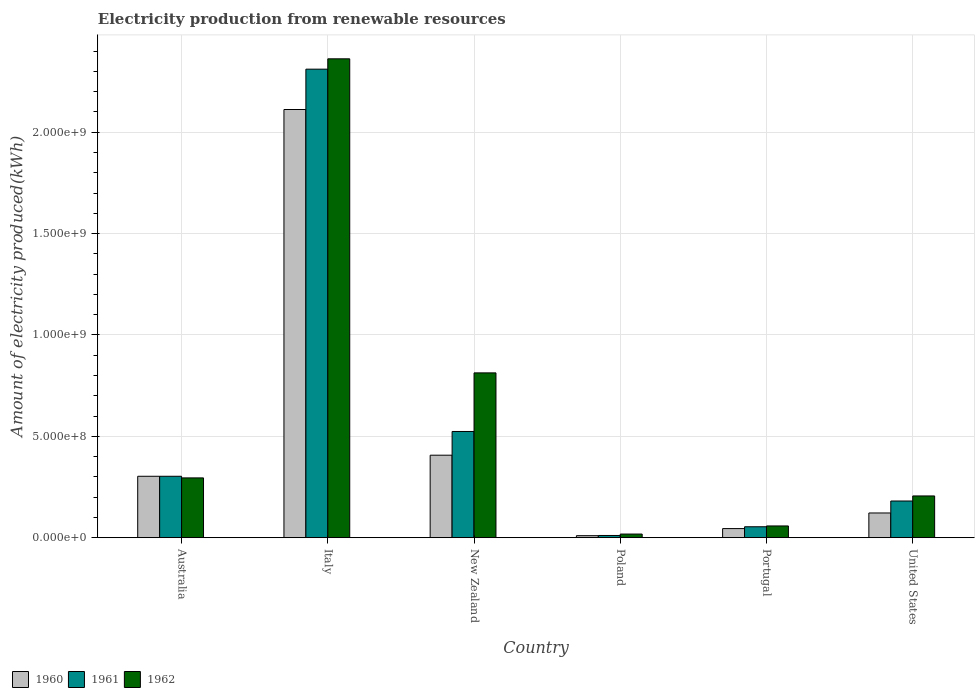How many different coloured bars are there?
Offer a terse response. 3. Are the number of bars on each tick of the X-axis equal?
Your answer should be very brief. Yes. How many bars are there on the 4th tick from the left?
Ensure brevity in your answer.  3. How many bars are there on the 3rd tick from the right?
Ensure brevity in your answer.  3. In how many cases, is the number of bars for a given country not equal to the number of legend labels?
Offer a very short reply. 0. What is the amount of electricity produced in 1961 in Portugal?
Keep it short and to the point. 5.40e+07. Across all countries, what is the maximum amount of electricity produced in 1960?
Give a very brief answer. 2.11e+09. Across all countries, what is the minimum amount of electricity produced in 1960?
Make the answer very short. 1.00e+07. In which country was the amount of electricity produced in 1962 maximum?
Provide a short and direct response. Italy. What is the total amount of electricity produced in 1960 in the graph?
Give a very brief answer. 3.00e+09. What is the difference between the amount of electricity produced in 1962 in Australia and that in Poland?
Offer a very short reply. 2.77e+08. What is the difference between the amount of electricity produced in 1961 in Portugal and the amount of electricity produced in 1962 in Italy?
Provide a short and direct response. -2.31e+09. What is the average amount of electricity produced in 1962 per country?
Your response must be concise. 6.25e+08. What is the difference between the amount of electricity produced of/in 1960 and amount of electricity produced of/in 1962 in United States?
Make the answer very short. -8.40e+07. What is the ratio of the amount of electricity produced in 1962 in Australia to that in United States?
Make the answer very short. 1.43. Is the amount of electricity produced in 1960 in Portugal less than that in United States?
Your response must be concise. Yes. Is the difference between the amount of electricity produced in 1960 in Australia and United States greater than the difference between the amount of electricity produced in 1962 in Australia and United States?
Your response must be concise. Yes. What is the difference between the highest and the second highest amount of electricity produced in 1961?
Offer a very short reply. 1.79e+09. What is the difference between the highest and the lowest amount of electricity produced in 1960?
Your answer should be compact. 2.10e+09. In how many countries, is the amount of electricity produced in 1962 greater than the average amount of electricity produced in 1962 taken over all countries?
Offer a very short reply. 2. Is the sum of the amount of electricity produced in 1961 in Australia and Italy greater than the maximum amount of electricity produced in 1962 across all countries?
Provide a short and direct response. Yes. How many countries are there in the graph?
Keep it short and to the point. 6. Does the graph contain any zero values?
Your answer should be compact. No. Does the graph contain grids?
Provide a short and direct response. Yes. What is the title of the graph?
Keep it short and to the point. Electricity production from renewable resources. What is the label or title of the X-axis?
Your answer should be compact. Country. What is the label or title of the Y-axis?
Offer a terse response. Amount of electricity produced(kWh). What is the Amount of electricity produced(kWh) in 1960 in Australia?
Your response must be concise. 3.03e+08. What is the Amount of electricity produced(kWh) of 1961 in Australia?
Ensure brevity in your answer.  3.03e+08. What is the Amount of electricity produced(kWh) of 1962 in Australia?
Make the answer very short. 2.95e+08. What is the Amount of electricity produced(kWh) in 1960 in Italy?
Provide a short and direct response. 2.11e+09. What is the Amount of electricity produced(kWh) in 1961 in Italy?
Keep it short and to the point. 2.31e+09. What is the Amount of electricity produced(kWh) of 1962 in Italy?
Provide a short and direct response. 2.36e+09. What is the Amount of electricity produced(kWh) of 1960 in New Zealand?
Offer a terse response. 4.07e+08. What is the Amount of electricity produced(kWh) of 1961 in New Zealand?
Provide a short and direct response. 5.24e+08. What is the Amount of electricity produced(kWh) of 1962 in New Zealand?
Your answer should be very brief. 8.13e+08. What is the Amount of electricity produced(kWh) in 1961 in Poland?
Provide a short and direct response. 1.10e+07. What is the Amount of electricity produced(kWh) in 1962 in Poland?
Your answer should be very brief. 1.80e+07. What is the Amount of electricity produced(kWh) in 1960 in Portugal?
Offer a very short reply. 4.50e+07. What is the Amount of electricity produced(kWh) in 1961 in Portugal?
Your answer should be compact. 5.40e+07. What is the Amount of electricity produced(kWh) of 1962 in Portugal?
Provide a short and direct response. 5.80e+07. What is the Amount of electricity produced(kWh) in 1960 in United States?
Keep it short and to the point. 1.22e+08. What is the Amount of electricity produced(kWh) in 1961 in United States?
Your answer should be very brief. 1.81e+08. What is the Amount of electricity produced(kWh) in 1962 in United States?
Your answer should be very brief. 2.06e+08. Across all countries, what is the maximum Amount of electricity produced(kWh) in 1960?
Make the answer very short. 2.11e+09. Across all countries, what is the maximum Amount of electricity produced(kWh) of 1961?
Your answer should be very brief. 2.31e+09. Across all countries, what is the maximum Amount of electricity produced(kWh) of 1962?
Ensure brevity in your answer.  2.36e+09. Across all countries, what is the minimum Amount of electricity produced(kWh) of 1961?
Offer a very short reply. 1.10e+07. Across all countries, what is the minimum Amount of electricity produced(kWh) in 1962?
Provide a short and direct response. 1.80e+07. What is the total Amount of electricity produced(kWh) in 1960 in the graph?
Give a very brief answer. 3.00e+09. What is the total Amount of electricity produced(kWh) of 1961 in the graph?
Give a very brief answer. 3.38e+09. What is the total Amount of electricity produced(kWh) of 1962 in the graph?
Offer a terse response. 3.75e+09. What is the difference between the Amount of electricity produced(kWh) of 1960 in Australia and that in Italy?
Keep it short and to the point. -1.81e+09. What is the difference between the Amount of electricity produced(kWh) in 1961 in Australia and that in Italy?
Offer a very short reply. -2.01e+09. What is the difference between the Amount of electricity produced(kWh) in 1962 in Australia and that in Italy?
Provide a succinct answer. -2.07e+09. What is the difference between the Amount of electricity produced(kWh) of 1960 in Australia and that in New Zealand?
Provide a short and direct response. -1.04e+08. What is the difference between the Amount of electricity produced(kWh) in 1961 in Australia and that in New Zealand?
Your answer should be very brief. -2.21e+08. What is the difference between the Amount of electricity produced(kWh) of 1962 in Australia and that in New Zealand?
Your response must be concise. -5.18e+08. What is the difference between the Amount of electricity produced(kWh) of 1960 in Australia and that in Poland?
Make the answer very short. 2.93e+08. What is the difference between the Amount of electricity produced(kWh) in 1961 in Australia and that in Poland?
Your response must be concise. 2.92e+08. What is the difference between the Amount of electricity produced(kWh) in 1962 in Australia and that in Poland?
Your answer should be very brief. 2.77e+08. What is the difference between the Amount of electricity produced(kWh) of 1960 in Australia and that in Portugal?
Offer a very short reply. 2.58e+08. What is the difference between the Amount of electricity produced(kWh) in 1961 in Australia and that in Portugal?
Provide a succinct answer. 2.49e+08. What is the difference between the Amount of electricity produced(kWh) in 1962 in Australia and that in Portugal?
Your response must be concise. 2.37e+08. What is the difference between the Amount of electricity produced(kWh) in 1960 in Australia and that in United States?
Your response must be concise. 1.81e+08. What is the difference between the Amount of electricity produced(kWh) in 1961 in Australia and that in United States?
Your answer should be compact. 1.22e+08. What is the difference between the Amount of electricity produced(kWh) in 1962 in Australia and that in United States?
Provide a succinct answer. 8.90e+07. What is the difference between the Amount of electricity produced(kWh) of 1960 in Italy and that in New Zealand?
Your answer should be compact. 1.70e+09. What is the difference between the Amount of electricity produced(kWh) of 1961 in Italy and that in New Zealand?
Make the answer very short. 1.79e+09. What is the difference between the Amount of electricity produced(kWh) in 1962 in Italy and that in New Zealand?
Give a very brief answer. 1.55e+09. What is the difference between the Amount of electricity produced(kWh) in 1960 in Italy and that in Poland?
Make the answer very short. 2.10e+09. What is the difference between the Amount of electricity produced(kWh) in 1961 in Italy and that in Poland?
Offer a terse response. 2.30e+09. What is the difference between the Amount of electricity produced(kWh) of 1962 in Italy and that in Poland?
Keep it short and to the point. 2.34e+09. What is the difference between the Amount of electricity produced(kWh) of 1960 in Italy and that in Portugal?
Offer a very short reply. 2.07e+09. What is the difference between the Amount of electricity produced(kWh) in 1961 in Italy and that in Portugal?
Provide a succinct answer. 2.26e+09. What is the difference between the Amount of electricity produced(kWh) in 1962 in Italy and that in Portugal?
Keep it short and to the point. 2.30e+09. What is the difference between the Amount of electricity produced(kWh) in 1960 in Italy and that in United States?
Provide a succinct answer. 1.99e+09. What is the difference between the Amount of electricity produced(kWh) in 1961 in Italy and that in United States?
Provide a succinct answer. 2.13e+09. What is the difference between the Amount of electricity produced(kWh) in 1962 in Italy and that in United States?
Keep it short and to the point. 2.16e+09. What is the difference between the Amount of electricity produced(kWh) in 1960 in New Zealand and that in Poland?
Keep it short and to the point. 3.97e+08. What is the difference between the Amount of electricity produced(kWh) of 1961 in New Zealand and that in Poland?
Provide a succinct answer. 5.13e+08. What is the difference between the Amount of electricity produced(kWh) of 1962 in New Zealand and that in Poland?
Your response must be concise. 7.95e+08. What is the difference between the Amount of electricity produced(kWh) of 1960 in New Zealand and that in Portugal?
Ensure brevity in your answer.  3.62e+08. What is the difference between the Amount of electricity produced(kWh) in 1961 in New Zealand and that in Portugal?
Provide a short and direct response. 4.70e+08. What is the difference between the Amount of electricity produced(kWh) of 1962 in New Zealand and that in Portugal?
Ensure brevity in your answer.  7.55e+08. What is the difference between the Amount of electricity produced(kWh) of 1960 in New Zealand and that in United States?
Your answer should be compact. 2.85e+08. What is the difference between the Amount of electricity produced(kWh) in 1961 in New Zealand and that in United States?
Keep it short and to the point. 3.43e+08. What is the difference between the Amount of electricity produced(kWh) in 1962 in New Zealand and that in United States?
Keep it short and to the point. 6.07e+08. What is the difference between the Amount of electricity produced(kWh) in 1960 in Poland and that in Portugal?
Offer a terse response. -3.50e+07. What is the difference between the Amount of electricity produced(kWh) of 1961 in Poland and that in Portugal?
Offer a terse response. -4.30e+07. What is the difference between the Amount of electricity produced(kWh) in 1962 in Poland and that in Portugal?
Your answer should be very brief. -4.00e+07. What is the difference between the Amount of electricity produced(kWh) in 1960 in Poland and that in United States?
Make the answer very short. -1.12e+08. What is the difference between the Amount of electricity produced(kWh) in 1961 in Poland and that in United States?
Offer a terse response. -1.70e+08. What is the difference between the Amount of electricity produced(kWh) of 1962 in Poland and that in United States?
Make the answer very short. -1.88e+08. What is the difference between the Amount of electricity produced(kWh) of 1960 in Portugal and that in United States?
Your answer should be very brief. -7.70e+07. What is the difference between the Amount of electricity produced(kWh) in 1961 in Portugal and that in United States?
Provide a short and direct response. -1.27e+08. What is the difference between the Amount of electricity produced(kWh) of 1962 in Portugal and that in United States?
Make the answer very short. -1.48e+08. What is the difference between the Amount of electricity produced(kWh) of 1960 in Australia and the Amount of electricity produced(kWh) of 1961 in Italy?
Offer a very short reply. -2.01e+09. What is the difference between the Amount of electricity produced(kWh) of 1960 in Australia and the Amount of electricity produced(kWh) of 1962 in Italy?
Your answer should be very brief. -2.06e+09. What is the difference between the Amount of electricity produced(kWh) of 1961 in Australia and the Amount of electricity produced(kWh) of 1962 in Italy?
Your answer should be compact. -2.06e+09. What is the difference between the Amount of electricity produced(kWh) in 1960 in Australia and the Amount of electricity produced(kWh) in 1961 in New Zealand?
Make the answer very short. -2.21e+08. What is the difference between the Amount of electricity produced(kWh) in 1960 in Australia and the Amount of electricity produced(kWh) in 1962 in New Zealand?
Your answer should be compact. -5.10e+08. What is the difference between the Amount of electricity produced(kWh) in 1961 in Australia and the Amount of electricity produced(kWh) in 1962 in New Zealand?
Make the answer very short. -5.10e+08. What is the difference between the Amount of electricity produced(kWh) in 1960 in Australia and the Amount of electricity produced(kWh) in 1961 in Poland?
Make the answer very short. 2.92e+08. What is the difference between the Amount of electricity produced(kWh) in 1960 in Australia and the Amount of electricity produced(kWh) in 1962 in Poland?
Keep it short and to the point. 2.85e+08. What is the difference between the Amount of electricity produced(kWh) in 1961 in Australia and the Amount of electricity produced(kWh) in 1962 in Poland?
Keep it short and to the point. 2.85e+08. What is the difference between the Amount of electricity produced(kWh) of 1960 in Australia and the Amount of electricity produced(kWh) of 1961 in Portugal?
Your answer should be compact. 2.49e+08. What is the difference between the Amount of electricity produced(kWh) in 1960 in Australia and the Amount of electricity produced(kWh) in 1962 in Portugal?
Give a very brief answer. 2.45e+08. What is the difference between the Amount of electricity produced(kWh) in 1961 in Australia and the Amount of electricity produced(kWh) in 1962 in Portugal?
Offer a very short reply. 2.45e+08. What is the difference between the Amount of electricity produced(kWh) of 1960 in Australia and the Amount of electricity produced(kWh) of 1961 in United States?
Make the answer very short. 1.22e+08. What is the difference between the Amount of electricity produced(kWh) of 1960 in Australia and the Amount of electricity produced(kWh) of 1962 in United States?
Ensure brevity in your answer.  9.70e+07. What is the difference between the Amount of electricity produced(kWh) of 1961 in Australia and the Amount of electricity produced(kWh) of 1962 in United States?
Offer a terse response. 9.70e+07. What is the difference between the Amount of electricity produced(kWh) of 1960 in Italy and the Amount of electricity produced(kWh) of 1961 in New Zealand?
Your response must be concise. 1.59e+09. What is the difference between the Amount of electricity produced(kWh) of 1960 in Italy and the Amount of electricity produced(kWh) of 1962 in New Zealand?
Offer a terse response. 1.30e+09. What is the difference between the Amount of electricity produced(kWh) in 1961 in Italy and the Amount of electricity produced(kWh) in 1962 in New Zealand?
Give a very brief answer. 1.50e+09. What is the difference between the Amount of electricity produced(kWh) of 1960 in Italy and the Amount of electricity produced(kWh) of 1961 in Poland?
Your answer should be compact. 2.10e+09. What is the difference between the Amount of electricity produced(kWh) of 1960 in Italy and the Amount of electricity produced(kWh) of 1962 in Poland?
Your answer should be very brief. 2.09e+09. What is the difference between the Amount of electricity produced(kWh) of 1961 in Italy and the Amount of electricity produced(kWh) of 1962 in Poland?
Your answer should be very brief. 2.29e+09. What is the difference between the Amount of electricity produced(kWh) of 1960 in Italy and the Amount of electricity produced(kWh) of 1961 in Portugal?
Make the answer very short. 2.06e+09. What is the difference between the Amount of electricity produced(kWh) in 1960 in Italy and the Amount of electricity produced(kWh) in 1962 in Portugal?
Your answer should be compact. 2.05e+09. What is the difference between the Amount of electricity produced(kWh) of 1961 in Italy and the Amount of electricity produced(kWh) of 1962 in Portugal?
Ensure brevity in your answer.  2.25e+09. What is the difference between the Amount of electricity produced(kWh) in 1960 in Italy and the Amount of electricity produced(kWh) in 1961 in United States?
Your answer should be very brief. 1.93e+09. What is the difference between the Amount of electricity produced(kWh) of 1960 in Italy and the Amount of electricity produced(kWh) of 1962 in United States?
Provide a succinct answer. 1.91e+09. What is the difference between the Amount of electricity produced(kWh) of 1961 in Italy and the Amount of electricity produced(kWh) of 1962 in United States?
Your answer should be very brief. 2.10e+09. What is the difference between the Amount of electricity produced(kWh) in 1960 in New Zealand and the Amount of electricity produced(kWh) in 1961 in Poland?
Your response must be concise. 3.96e+08. What is the difference between the Amount of electricity produced(kWh) of 1960 in New Zealand and the Amount of electricity produced(kWh) of 1962 in Poland?
Your answer should be compact. 3.89e+08. What is the difference between the Amount of electricity produced(kWh) in 1961 in New Zealand and the Amount of electricity produced(kWh) in 1962 in Poland?
Offer a very short reply. 5.06e+08. What is the difference between the Amount of electricity produced(kWh) of 1960 in New Zealand and the Amount of electricity produced(kWh) of 1961 in Portugal?
Make the answer very short. 3.53e+08. What is the difference between the Amount of electricity produced(kWh) of 1960 in New Zealand and the Amount of electricity produced(kWh) of 1962 in Portugal?
Offer a terse response. 3.49e+08. What is the difference between the Amount of electricity produced(kWh) in 1961 in New Zealand and the Amount of electricity produced(kWh) in 1962 in Portugal?
Your answer should be compact. 4.66e+08. What is the difference between the Amount of electricity produced(kWh) of 1960 in New Zealand and the Amount of electricity produced(kWh) of 1961 in United States?
Your answer should be compact. 2.26e+08. What is the difference between the Amount of electricity produced(kWh) of 1960 in New Zealand and the Amount of electricity produced(kWh) of 1962 in United States?
Ensure brevity in your answer.  2.01e+08. What is the difference between the Amount of electricity produced(kWh) of 1961 in New Zealand and the Amount of electricity produced(kWh) of 1962 in United States?
Your response must be concise. 3.18e+08. What is the difference between the Amount of electricity produced(kWh) in 1960 in Poland and the Amount of electricity produced(kWh) in 1961 in Portugal?
Provide a succinct answer. -4.40e+07. What is the difference between the Amount of electricity produced(kWh) of 1960 in Poland and the Amount of electricity produced(kWh) of 1962 in Portugal?
Provide a short and direct response. -4.80e+07. What is the difference between the Amount of electricity produced(kWh) of 1961 in Poland and the Amount of electricity produced(kWh) of 1962 in Portugal?
Keep it short and to the point. -4.70e+07. What is the difference between the Amount of electricity produced(kWh) in 1960 in Poland and the Amount of electricity produced(kWh) in 1961 in United States?
Provide a succinct answer. -1.71e+08. What is the difference between the Amount of electricity produced(kWh) in 1960 in Poland and the Amount of electricity produced(kWh) in 1962 in United States?
Give a very brief answer. -1.96e+08. What is the difference between the Amount of electricity produced(kWh) of 1961 in Poland and the Amount of electricity produced(kWh) of 1962 in United States?
Your answer should be compact. -1.95e+08. What is the difference between the Amount of electricity produced(kWh) in 1960 in Portugal and the Amount of electricity produced(kWh) in 1961 in United States?
Keep it short and to the point. -1.36e+08. What is the difference between the Amount of electricity produced(kWh) in 1960 in Portugal and the Amount of electricity produced(kWh) in 1962 in United States?
Your answer should be compact. -1.61e+08. What is the difference between the Amount of electricity produced(kWh) of 1961 in Portugal and the Amount of electricity produced(kWh) of 1962 in United States?
Your answer should be compact. -1.52e+08. What is the average Amount of electricity produced(kWh) of 1960 per country?
Give a very brief answer. 5.00e+08. What is the average Amount of electricity produced(kWh) in 1961 per country?
Your answer should be compact. 5.64e+08. What is the average Amount of electricity produced(kWh) in 1962 per country?
Keep it short and to the point. 6.25e+08. What is the difference between the Amount of electricity produced(kWh) in 1960 and Amount of electricity produced(kWh) in 1961 in Australia?
Offer a very short reply. 0. What is the difference between the Amount of electricity produced(kWh) of 1960 and Amount of electricity produced(kWh) of 1961 in Italy?
Offer a very short reply. -1.99e+08. What is the difference between the Amount of electricity produced(kWh) in 1960 and Amount of electricity produced(kWh) in 1962 in Italy?
Make the answer very short. -2.50e+08. What is the difference between the Amount of electricity produced(kWh) in 1961 and Amount of electricity produced(kWh) in 1962 in Italy?
Provide a succinct answer. -5.10e+07. What is the difference between the Amount of electricity produced(kWh) of 1960 and Amount of electricity produced(kWh) of 1961 in New Zealand?
Keep it short and to the point. -1.17e+08. What is the difference between the Amount of electricity produced(kWh) in 1960 and Amount of electricity produced(kWh) in 1962 in New Zealand?
Keep it short and to the point. -4.06e+08. What is the difference between the Amount of electricity produced(kWh) in 1961 and Amount of electricity produced(kWh) in 1962 in New Zealand?
Provide a short and direct response. -2.89e+08. What is the difference between the Amount of electricity produced(kWh) of 1960 and Amount of electricity produced(kWh) of 1962 in Poland?
Offer a very short reply. -8.00e+06. What is the difference between the Amount of electricity produced(kWh) in 1961 and Amount of electricity produced(kWh) in 1962 in Poland?
Ensure brevity in your answer.  -7.00e+06. What is the difference between the Amount of electricity produced(kWh) in 1960 and Amount of electricity produced(kWh) in 1961 in Portugal?
Keep it short and to the point. -9.00e+06. What is the difference between the Amount of electricity produced(kWh) of 1960 and Amount of electricity produced(kWh) of 1962 in Portugal?
Ensure brevity in your answer.  -1.30e+07. What is the difference between the Amount of electricity produced(kWh) of 1961 and Amount of electricity produced(kWh) of 1962 in Portugal?
Offer a very short reply. -4.00e+06. What is the difference between the Amount of electricity produced(kWh) of 1960 and Amount of electricity produced(kWh) of 1961 in United States?
Ensure brevity in your answer.  -5.90e+07. What is the difference between the Amount of electricity produced(kWh) in 1960 and Amount of electricity produced(kWh) in 1962 in United States?
Your response must be concise. -8.40e+07. What is the difference between the Amount of electricity produced(kWh) in 1961 and Amount of electricity produced(kWh) in 1962 in United States?
Make the answer very short. -2.50e+07. What is the ratio of the Amount of electricity produced(kWh) of 1960 in Australia to that in Italy?
Your response must be concise. 0.14. What is the ratio of the Amount of electricity produced(kWh) in 1961 in Australia to that in Italy?
Your response must be concise. 0.13. What is the ratio of the Amount of electricity produced(kWh) in 1962 in Australia to that in Italy?
Provide a short and direct response. 0.12. What is the ratio of the Amount of electricity produced(kWh) of 1960 in Australia to that in New Zealand?
Ensure brevity in your answer.  0.74. What is the ratio of the Amount of electricity produced(kWh) of 1961 in Australia to that in New Zealand?
Your answer should be compact. 0.58. What is the ratio of the Amount of electricity produced(kWh) in 1962 in Australia to that in New Zealand?
Make the answer very short. 0.36. What is the ratio of the Amount of electricity produced(kWh) in 1960 in Australia to that in Poland?
Offer a very short reply. 30.3. What is the ratio of the Amount of electricity produced(kWh) of 1961 in Australia to that in Poland?
Your answer should be compact. 27.55. What is the ratio of the Amount of electricity produced(kWh) in 1962 in Australia to that in Poland?
Ensure brevity in your answer.  16.39. What is the ratio of the Amount of electricity produced(kWh) of 1960 in Australia to that in Portugal?
Your response must be concise. 6.73. What is the ratio of the Amount of electricity produced(kWh) of 1961 in Australia to that in Portugal?
Keep it short and to the point. 5.61. What is the ratio of the Amount of electricity produced(kWh) of 1962 in Australia to that in Portugal?
Give a very brief answer. 5.09. What is the ratio of the Amount of electricity produced(kWh) in 1960 in Australia to that in United States?
Provide a succinct answer. 2.48. What is the ratio of the Amount of electricity produced(kWh) in 1961 in Australia to that in United States?
Your response must be concise. 1.67. What is the ratio of the Amount of electricity produced(kWh) of 1962 in Australia to that in United States?
Make the answer very short. 1.43. What is the ratio of the Amount of electricity produced(kWh) of 1960 in Italy to that in New Zealand?
Give a very brief answer. 5.19. What is the ratio of the Amount of electricity produced(kWh) in 1961 in Italy to that in New Zealand?
Ensure brevity in your answer.  4.41. What is the ratio of the Amount of electricity produced(kWh) in 1962 in Italy to that in New Zealand?
Your response must be concise. 2.91. What is the ratio of the Amount of electricity produced(kWh) of 1960 in Italy to that in Poland?
Your answer should be compact. 211.2. What is the ratio of the Amount of electricity produced(kWh) in 1961 in Italy to that in Poland?
Provide a short and direct response. 210.09. What is the ratio of the Amount of electricity produced(kWh) of 1962 in Italy to that in Poland?
Offer a very short reply. 131.22. What is the ratio of the Amount of electricity produced(kWh) of 1960 in Italy to that in Portugal?
Provide a succinct answer. 46.93. What is the ratio of the Amount of electricity produced(kWh) of 1961 in Italy to that in Portugal?
Your response must be concise. 42.8. What is the ratio of the Amount of electricity produced(kWh) in 1962 in Italy to that in Portugal?
Provide a short and direct response. 40.72. What is the ratio of the Amount of electricity produced(kWh) of 1960 in Italy to that in United States?
Your response must be concise. 17.31. What is the ratio of the Amount of electricity produced(kWh) in 1961 in Italy to that in United States?
Your response must be concise. 12.77. What is the ratio of the Amount of electricity produced(kWh) in 1962 in Italy to that in United States?
Make the answer very short. 11.47. What is the ratio of the Amount of electricity produced(kWh) in 1960 in New Zealand to that in Poland?
Make the answer very short. 40.7. What is the ratio of the Amount of electricity produced(kWh) in 1961 in New Zealand to that in Poland?
Your answer should be compact. 47.64. What is the ratio of the Amount of electricity produced(kWh) of 1962 in New Zealand to that in Poland?
Your answer should be compact. 45.17. What is the ratio of the Amount of electricity produced(kWh) in 1960 in New Zealand to that in Portugal?
Offer a very short reply. 9.04. What is the ratio of the Amount of electricity produced(kWh) of 1961 in New Zealand to that in Portugal?
Offer a very short reply. 9.7. What is the ratio of the Amount of electricity produced(kWh) in 1962 in New Zealand to that in Portugal?
Your response must be concise. 14.02. What is the ratio of the Amount of electricity produced(kWh) in 1960 in New Zealand to that in United States?
Make the answer very short. 3.34. What is the ratio of the Amount of electricity produced(kWh) of 1961 in New Zealand to that in United States?
Provide a succinct answer. 2.9. What is the ratio of the Amount of electricity produced(kWh) of 1962 in New Zealand to that in United States?
Ensure brevity in your answer.  3.95. What is the ratio of the Amount of electricity produced(kWh) of 1960 in Poland to that in Portugal?
Your response must be concise. 0.22. What is the ratio of the Amount of electricity produced(kWh) in 1961 in Poland to that in Portugal?
Provide a succinct answer. 0.2. What is the ratio of the Amount of electricity produced(kWh) in 1962 in Poland to that in Portugal?
Keep it short and to the point. 0.31. What is the ratio of the Amount of electricity produced(kWh) in 1960 in Poland to that in United States?
Offer a terse response. 0.08. What is the ratio of the Amount of electricity produced(kWh) in 1961 in Poland to that in United States?
Give a very brief answer. 0.06. What is the ratio of the Amount of electricity produced(kWh) of 1962 in Poland to that in United States?
Your response must be concise. 0.09. What is the ratio of the Amount of electricity produced(kWh) in 1960 in Portugal to that in United States?
Your response must be concise. 0.37. What is the ratio of the Amount of electricity produced(kWh) in 1961 in Portugal to that in United States?
Keep it short and to the point. 0.3. What is the ratio of the Amount of electricity produced(kWh) of 1962 in Portugal to that in United States?
Provide a succinct answer. 0.28. What is the difference between the highest and the second highest Amount of electricity produced(kWh) of 1960?
Your response must be concise. 1.70e+09. What is the difference between the highest and the second highest Amount of electricity produced(kWh) of 1961?
Your answer should be very brief. 1.79e+09. What is the difference between the highest and the second highest Amount of electricity produced(kWh) of 1962?
Provide a short and direct response. 1.55e+09. What is the difference between the highest and the lowest Amount of electricity produced(kWh) in 1960?
Keep it short and to the point. 2.10e+09. What is the difference between the highest and the lowest Amount of electricity produced(kWh) in 1961?
Offer a terse response. 2.30e+09. What is the difference between the highest and the lowest Amount of electricity produced(kWh) of 1962?
Provide a short and direct response. 2.34e+09. 